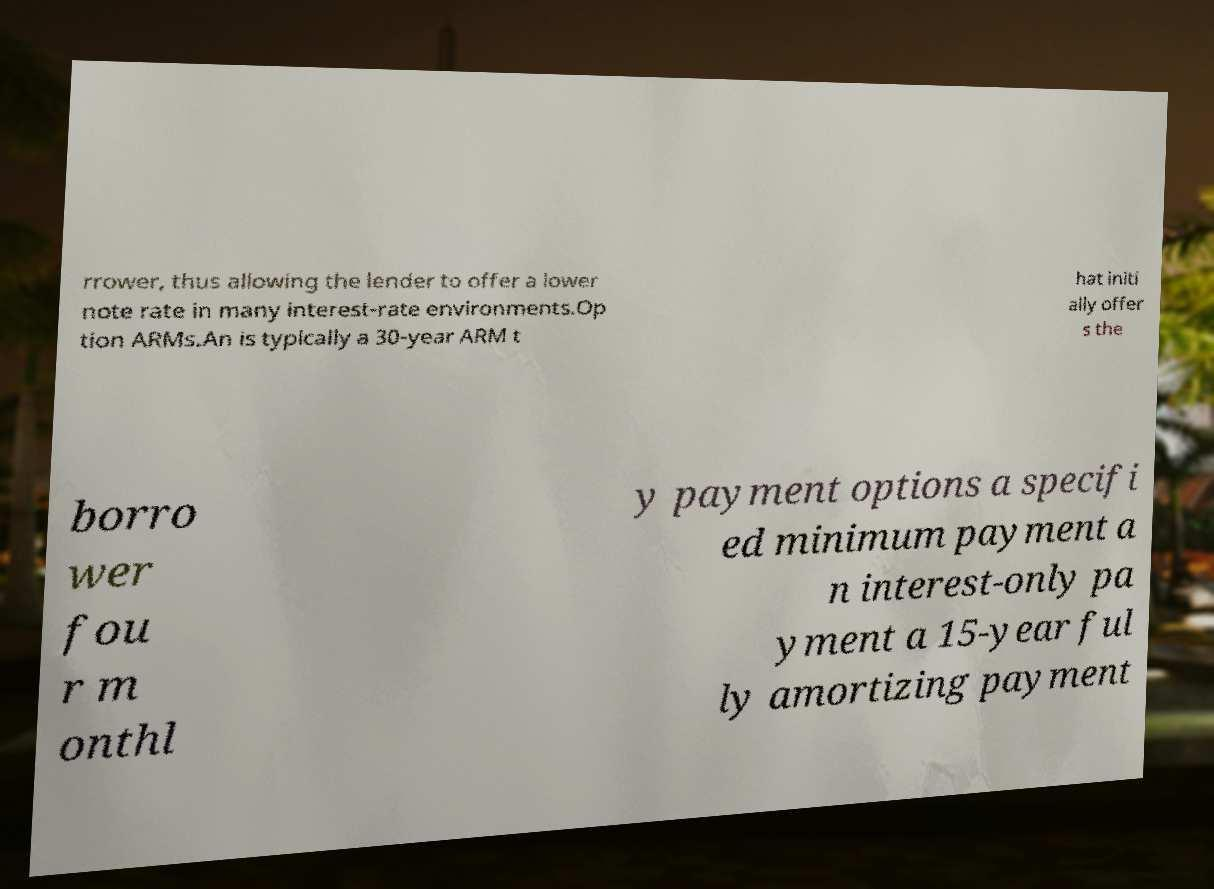Could you extract and type out the text from this image? rrower, thus allowing the lender to offer a lower note rate in many interest-rate environments.Op tion ARMs.An is typically a 30-year ARM t hat initi ally offer s the borro wer fou r m onthl y payment options a specifi ed minimum payment a n interest-only pa yment a 15-year ful ly amortizing payment 